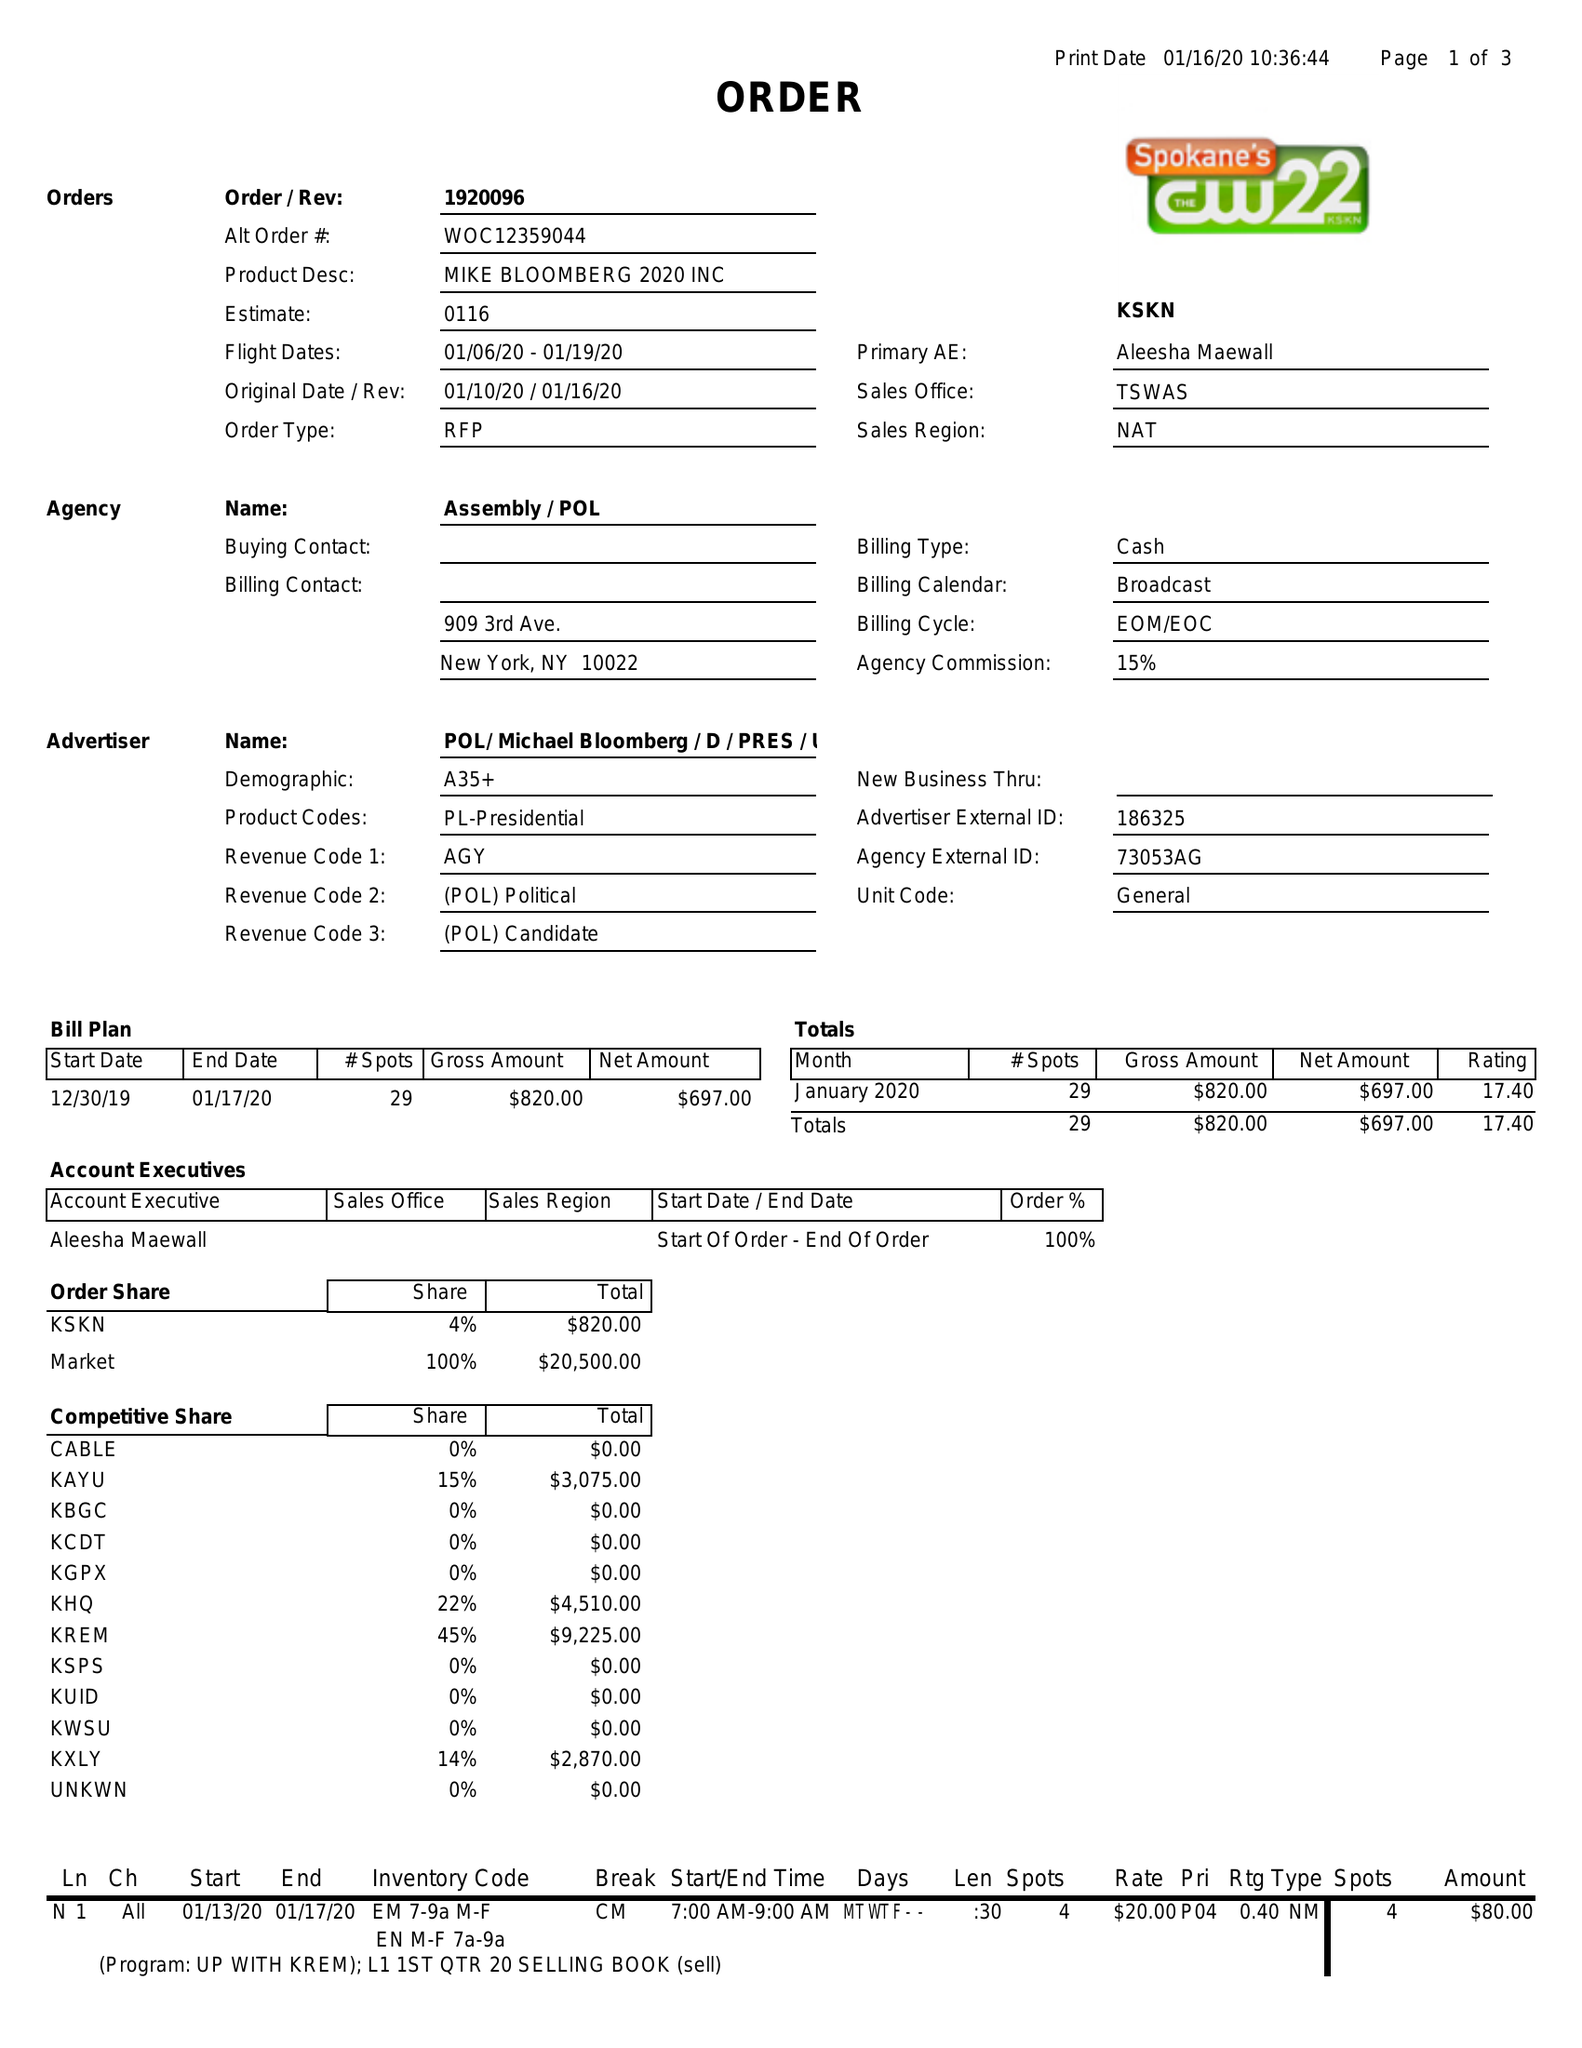What is the value for the flight_from?
Answer the question using a single word or phrase. 01/06/20 